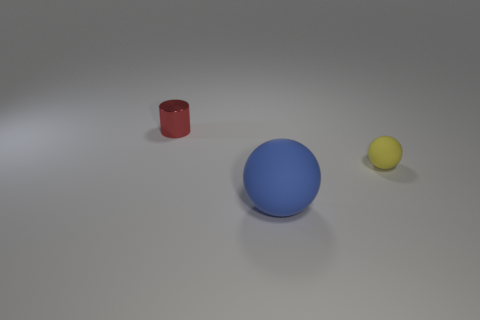Subtract all blue spheres. How many spheres are left? 1 Add 2 shiny objects. How many objects exist? 5 Subtract all spheres. How many objects are left? 1 Subtract all blue spheres. Subtract all cyan cubes. How many spheres are left? 1 Subtract all tiny metallic cubes. Subtract all tiny red objects. How many objects are left? 2 Add 1 tiny matte balls. How many tiny matte balls are left? 2 Add 3 yellow matte balls. How many yellow matte balls exist? 4 Subtract 0 gray cylinders. How many objects are left? 3 